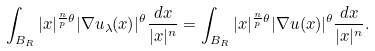<formula> <loc_0><loc_0><loc_500><loc_500>\int _ { B _ { R } } | x | ^ { \frac { n } { p } \theta } | \nabla u _ { \lambda } ( x ) | ^ { \theta } \frac { d x } { | x | ^ { n } } = \int _ { B _ { R } } | x | ^ { \frac { n } { p } \theta } | \nabla u ( x ) | ^ { \theta } \frac { d x } { | x | ^ { n } } .</formula> 